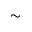<formula> <loc_0><loc_0><loc_500><loc_500>\simeq</formula> 